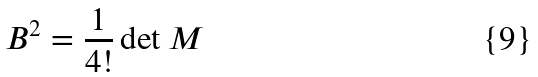<formula> <loc_0><loc_0><loc_500><loc_500>B ^ { 2 } = \frac { 1 } { 4 ! } \det M</formula> 